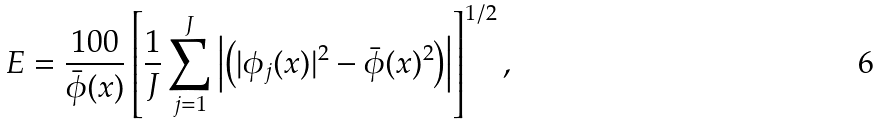Convert formula to latex. <formula><loc_0><loc_0><loc_500><loc_500>E = \frac { 1 0 0 } { \bar { \phi } ( x ) } \left [ \frac { 1 } { J } \sum _ { j = 1 } ^ { J } \left | \left ( | \phi _ { j } ( x ) | ^ { 2 } - \bar { \phi } ( x ) ^ { 2 } \right ) \right | \right ] ^ { 1 / 2 } ,</formula> 